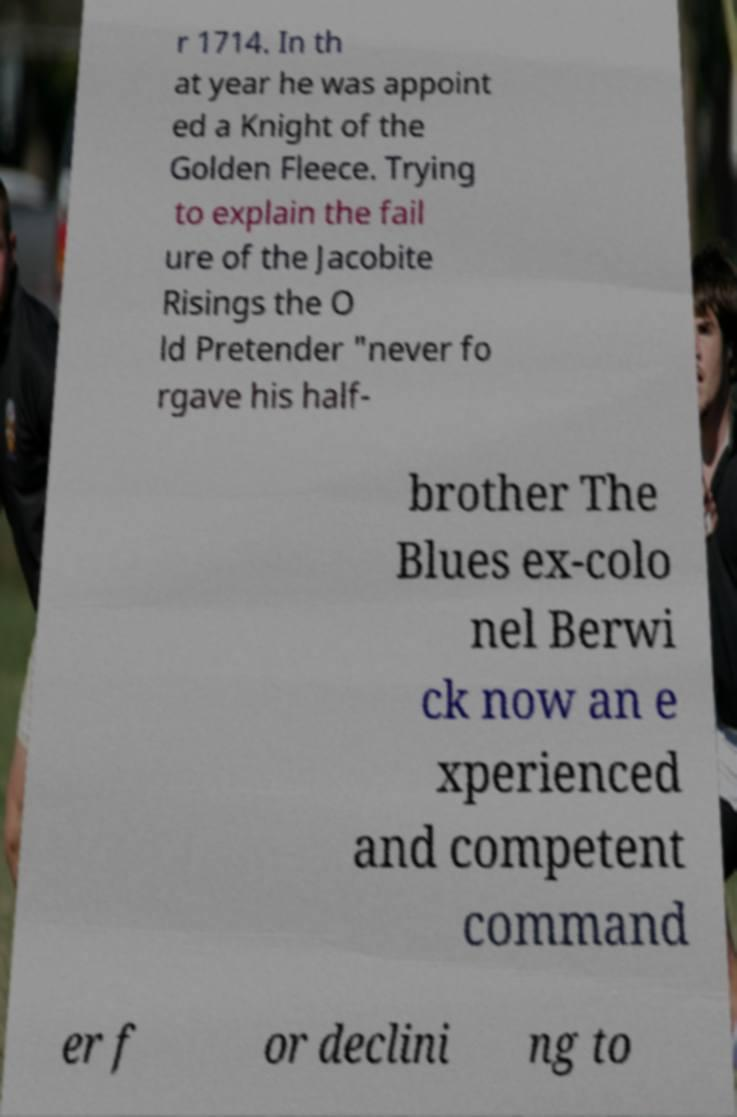Please read and relay the text visible in this image. What does it say? r 1714. In th at year he was appoint ed a Knight of the Golden Fleece. Trying to explain the fail ure of the Jacobite Risings the O ld Pretender "never fo rgave his half- brother The Blues ex-colo nel Berwi ck now an e xperienced and competent command er f or declini ng to 